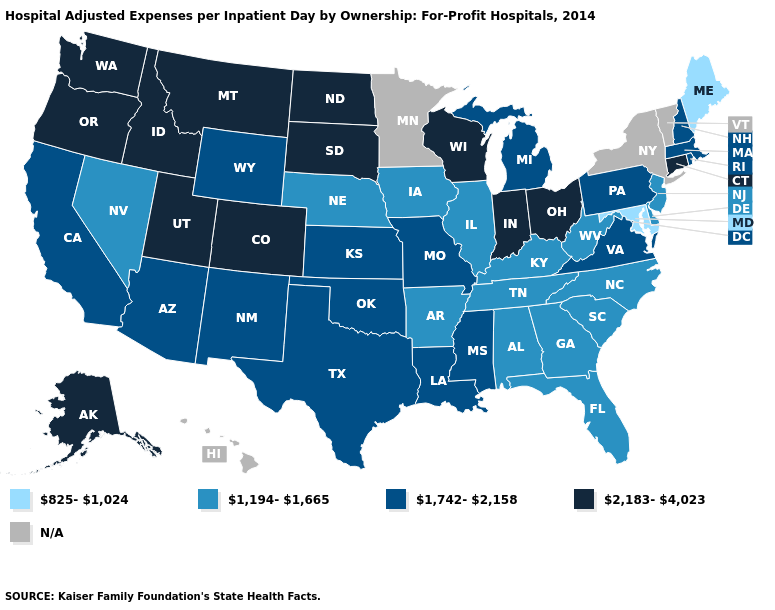What is the value of South Dakota?
Be succinct. 2,183-4,023. Name the states that have a value in the range 1,194-1,665?
Short answer required. Alabama, Arkansas, Delaware, Florida, Georgia, Illinois, Iowa, Kentucky, Nebraska, Nevada, New Jersey, North Carolina, South Carolina, Tennessee, West Virginia. What is the value of Nebraska?
Write a very short answer. 1,194-1,665. What is the value of Kentucky?
Answer briefly. 1,194-1,665. What is the highest value in states that border Maryland?
Answer briefly. 1,742-2,158. Which states have the lowest value in the USA?
Concise answer only. Maine, Maryland. Name the states that have a value in the range 825-1,024?
Write a very short answer. Maine, Maryland. Does Texas have the lowest value in the USA?
Be succinct. No. What is the value of Oklahoma?
Answer briefly. 1,742-2,158. What is the highest value in the USA?
Concise answer only. 2,183-4,023. What is the highest value in the South ?
Concise answer only. 1,742-2,158. What is the value of Louisiana?
Concise answer only. 1,742-2,158. What is the lowest value in the South?
Short answer required. 825-1,024. 